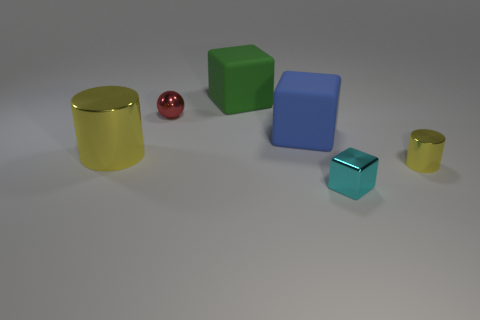What shape is the yellow thing that is left of the metallic block?
Give a very brief answer. Cylinder. What number of objects are cyan shiny spheres or metal cylinders that are right of the tiny block?
Give a very brief answer. 1. Are the green cube and the tiny yellow cylinder made of the same material?
Offer a very short reply. No. Are there an equal number of balls that are behind the red object and cyan shiny objects behind the small yellow metal object?
Make the answer very short. Yes. There is a tiny red object; what number of large matte blocks are behind it?
Provide a short and direct response. 1. What number of objects are either tiny red metallic balls or green rubber objects?
Give a very brief answer. 2. What number of blue objects have the same size as the cyan object?
Give a very brief answer. 0. What shape is the small yellow object that is to the right of the yellow shiny object on the left side of the small yellow shiny cylinder?
Ensure brevity in your answer.  Cylinder. Is the number of objects less than the number of brown rubber blocks?
Give a very brief answer. No. What color is the big thing in front of the blue cube?
Provide a succinct answer. Yellow. 